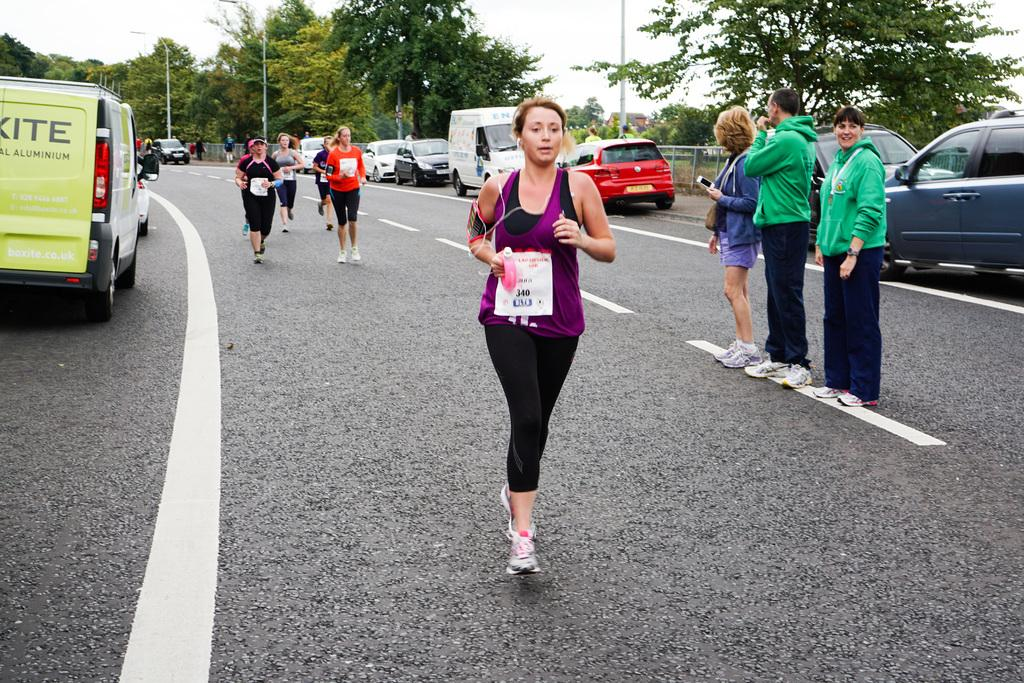<image>
Summarize the visual content of the image. Runner number 340 is in the lead of a marathon as she runs bast a group of three people. 